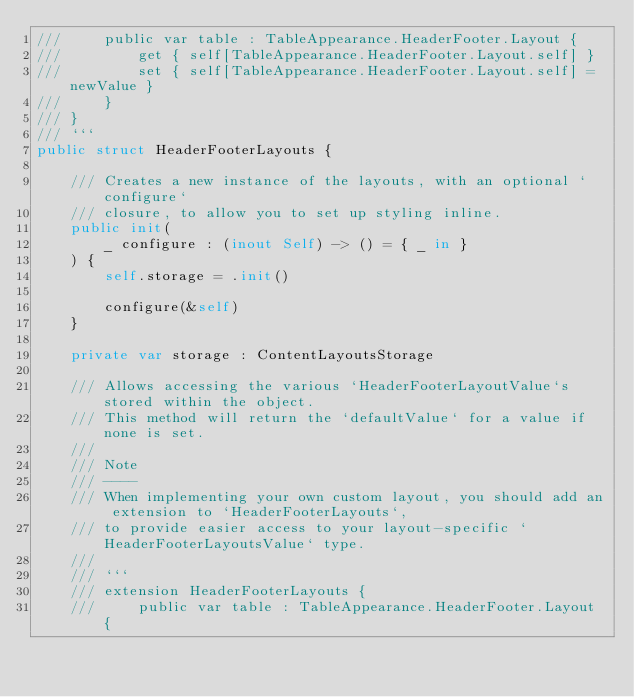Convert code to text. <code><loc_0><loc_0><loc_500><loc_500><_Swift_>///     public var table : TableAppearance.HeaderFooter.Layout {
///         get { self[TableAppearance.HeaderFooter.Layout.self] }
///         set { self[TableAppearance.HeaderFooter.Layout.self] = newValue }
///     }
/// }
/// ```
public struct HeaderFooterLayouts {
    
    /// Creates a new instance of the layouts, with an optional `configure`
    /// closure, to allow you to set up styling inline.
    public init(
        _ configure : (inout Self) -> () = { _ in }
    ) {
        self.storage = .init()
        
        configure(&self)
    }
    
    private var storage : ContentLayoutsStorage
    
    /// Allows accessing the various `HeaderFooterLayoutValue`s stored within the object.
    /// This method will return the `defaultValue` for a value if none is set.
    ///
    /// Note
    /// ----
    /// When implementing your own custom layout, you should add an extension to `HeaderFooterLayouts`,
    /// to provide easier access to your layout-specific `HeaderFooterLayoutsValue` type.
    ///
    /// ```
    /// extension HeaderFooterLayouts {
    ///     public var table : TableAppearance.HeaderFooter.Layout {</code> 